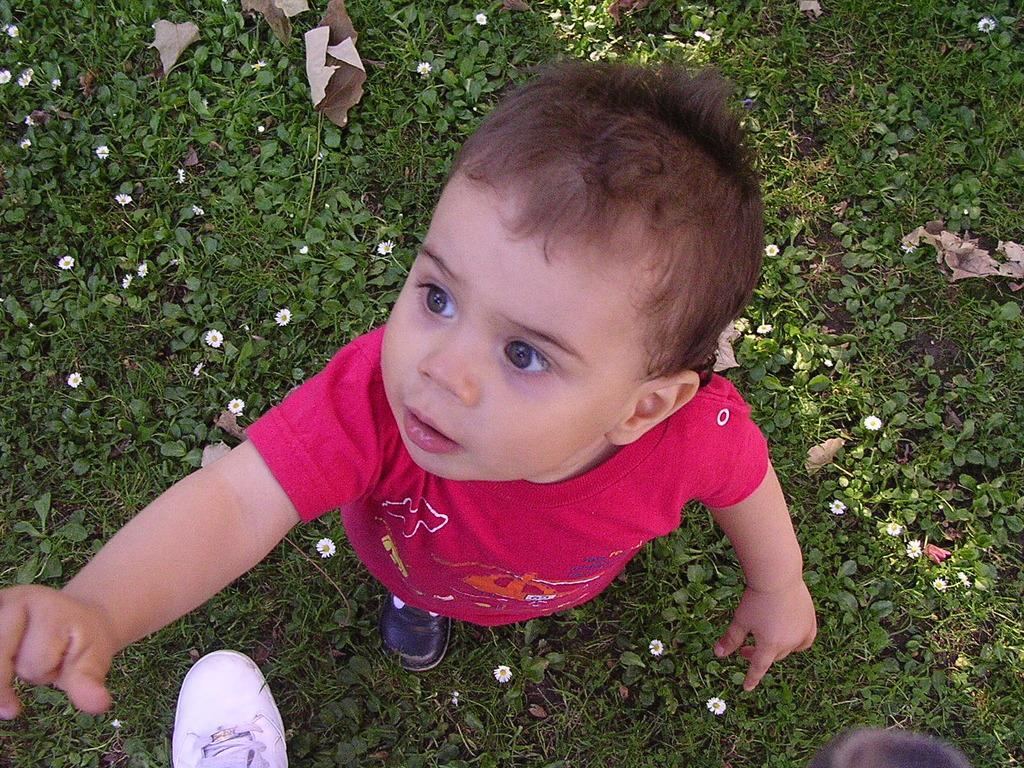How would you summarize this image in a sentence or two? In this image we can see a kid standing on the ground, there are few plants with flowers and there is a shoe near the kid. 